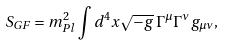Convert formula to latex. <formula><loc_0><loc_0><loc_500><loc_500>S _ { G F } = m _ { P l } ^ { 2 } \int d ^ { 4 } x \sqrt { - g } \, \Gamma ^ { \mu } \Gamma ^ { \nu } g _ { \mu \nu } ,</formula> 